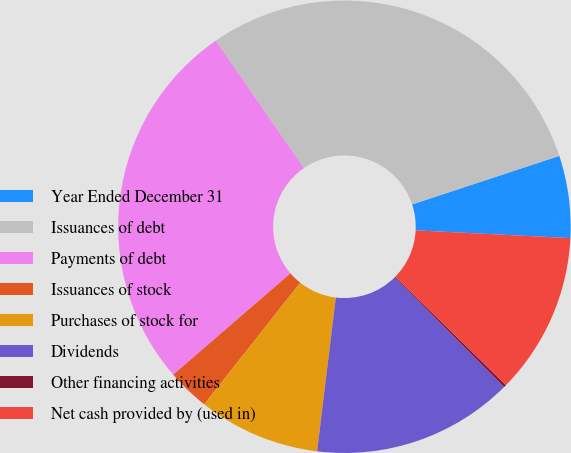Convert chart to OTSL. <chart><loc_0><loc_0><loc_500><loc_500><pie_chart><fcel>Year Ended December 31<fcel>Issuances of debt<fcel>Payments of debt<fcel>Issuances of stock<fcel>Purchases of stock for<fcel>Dividends<fcel>Other financing activities<fcel>Net cash provided by (used in)<nl><fcel>5.87%<fcel>29.56%<fcel>26.71%<fcel>3.02%<fcel>8.71%<fcel>14.4%<fcel>0.18%<fcel>11.55%<nl></chart> 